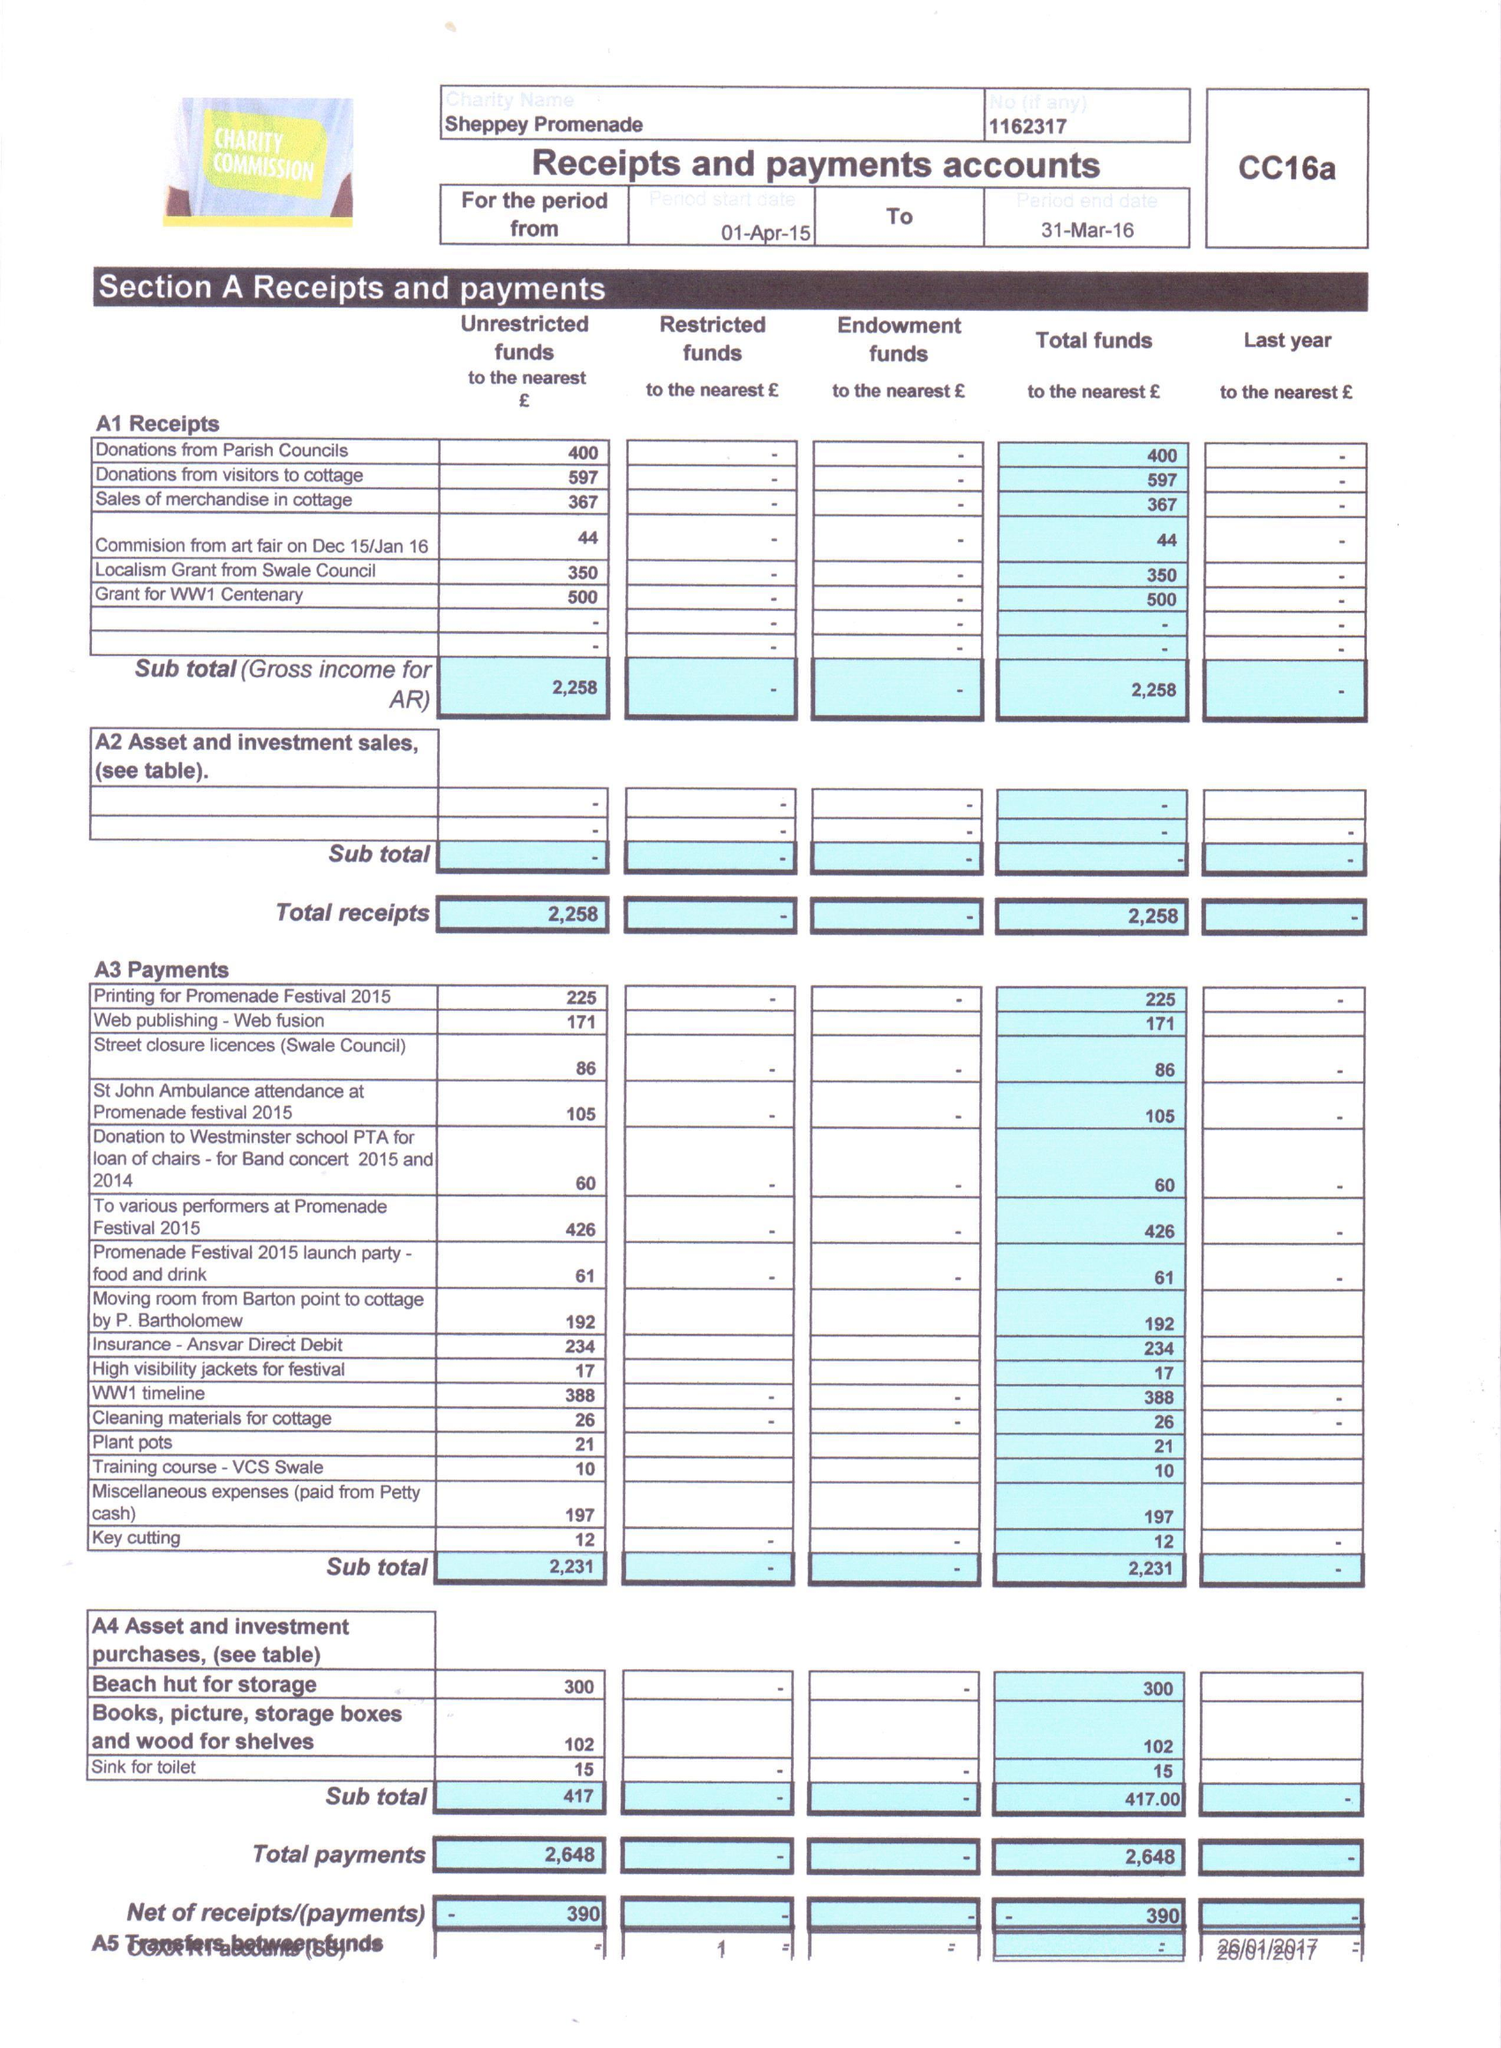What is the value for the address__street_line?
Answer the question using a single word or phrase. 10 ROSE STREET 